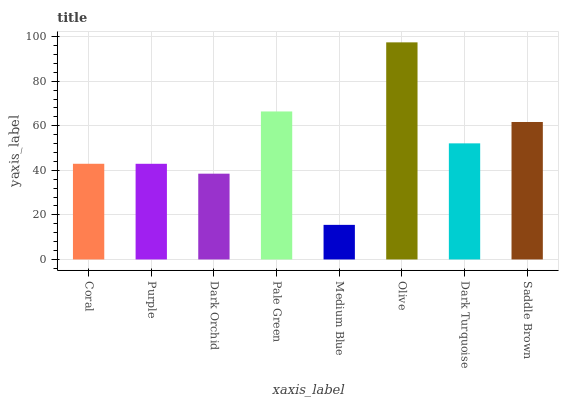Is Medium Blue the minimum?
Answer yes or no. Yes. Is Olive the maximum?
Answer yes or no. Yes. Is Purple the minimum?
Answer yes or no. No. Is Purple the maximum?
Answer yes or no. No. Is Coral greater than Purple?
Answer yes or no. Yes. Is Purple less than Coral?
Answer yes or no. Yes. Is Purple greater than Coral?
Answer yes or no. No. Is Coral less than Purple?
Answer yes or no. No. Is Dark Turquoise the high median?
Answer yes or no. Yes. Is Coral the low median?
Answer yes or no. Yes. Is Medium Blue the high median?
Answer yes or no. No. Is Olive the low median?
Answer yes or no. No. 